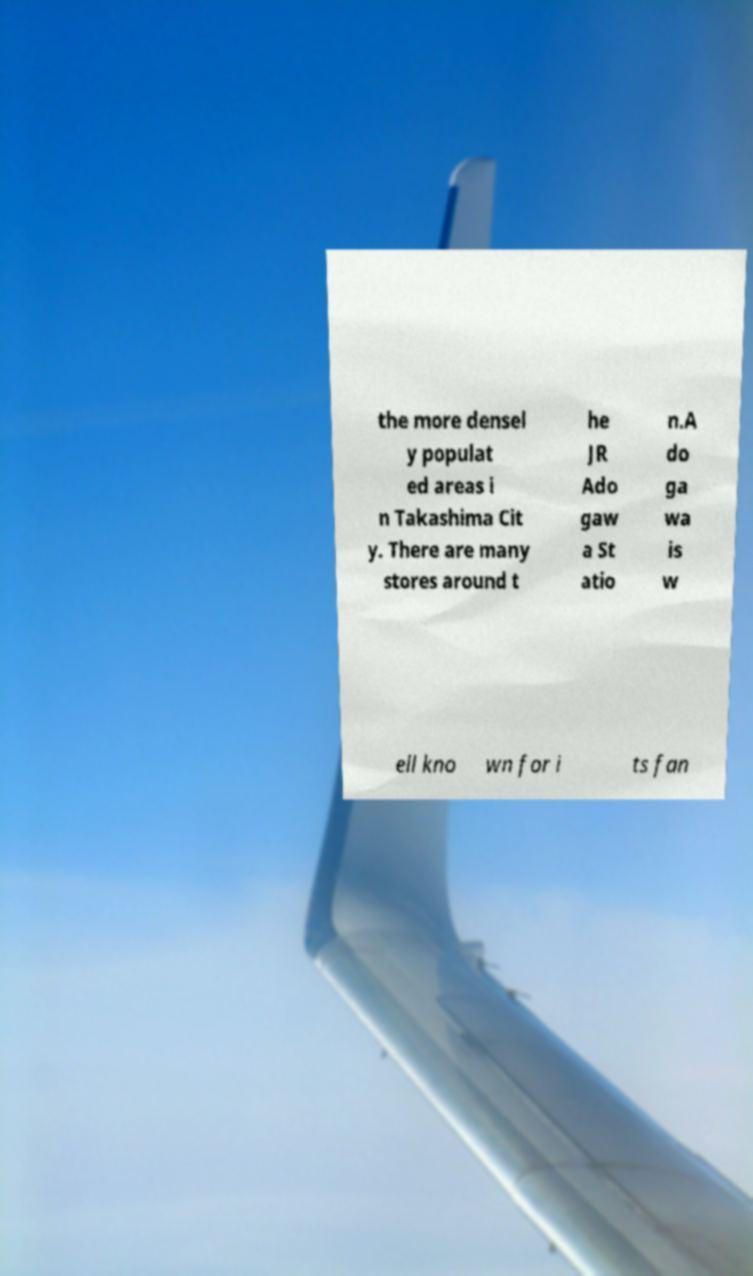What messages or text are displayed in this image? I need them in a readable, typed format. the more densel y populat ed areas i n Takashima Cit y. There are many stores around t he JR Ado gaw a St atio n.A do ga wa is w ell kno wn for i ts fan 